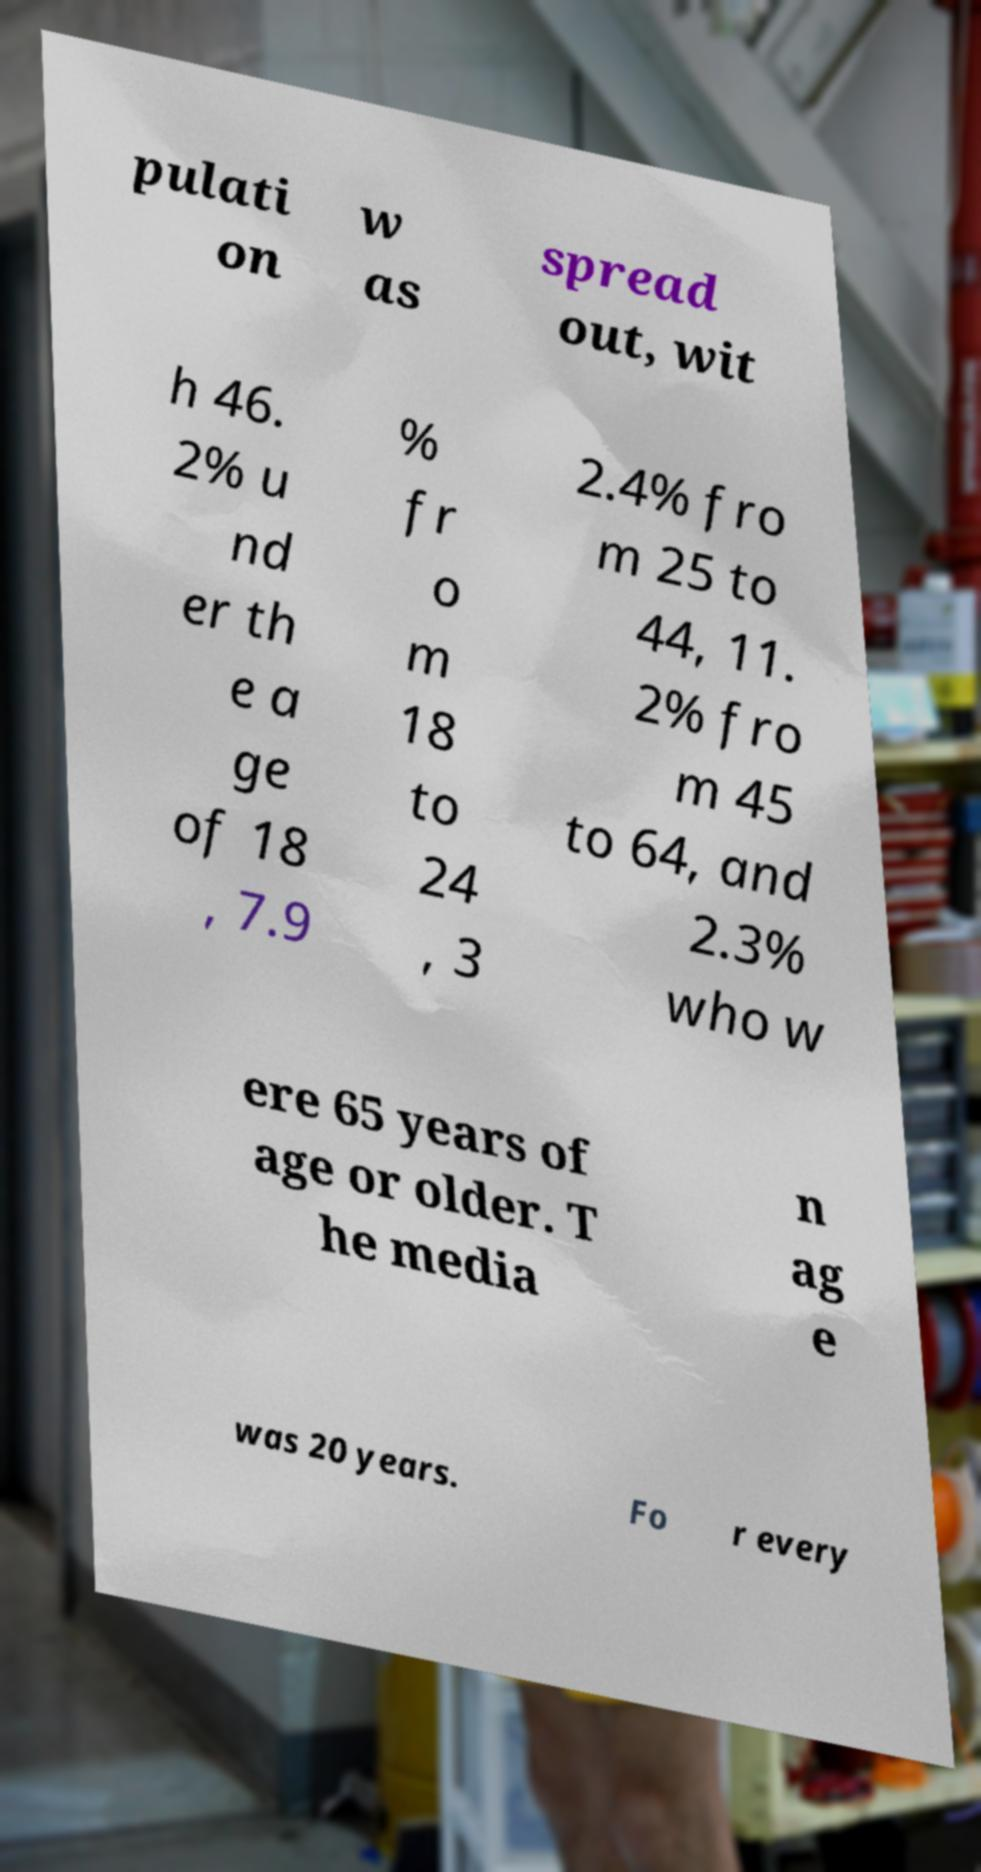Please identify and transcribe the text found in this image. pulati on w as spread out, wit h 46. 2% u nd er th e a ge of 18 , 7.9 % fr o m 18 to 24 , 3 2.4% fro m 25 to 44, 11. 2% fro m 45 to 64, and 2.3% who w ere 65 years of age or older. T he media n ag e was 20 years. Fo r every 